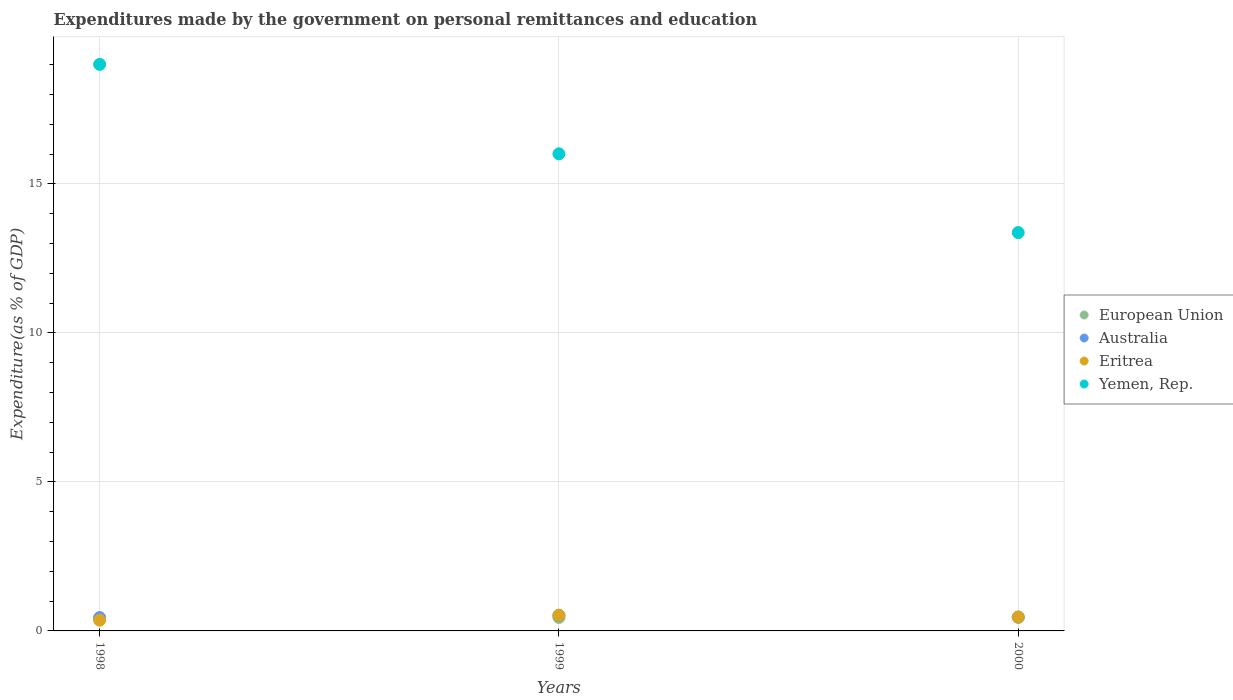How many different coloured dotlines are there?
Keep it short and to the point. 4. What is the expenditures made by the government on personal remittances and education in European Union in 2000?
Offer a terse response. 0.47. Across all years, what is the maximum expenditures made by the government on personal remittances and education in Eritrea?
Provide a succinct answer. 0.53. Across all years, what is the minimum expenditures made by the government on personal remittances and education in Yemen, Rep.?
Make the answer very short. 13.37. In which year was the expenditures made by the government on personal remittances and education in European Union maximum?
Keep it short and to the point. 2000. In which year was the expenditures made by the government on personal remittances and education in Eritrea minimum?
Provide a short and direct response. 1998. What is the total expenditures made by the government on personal remittances and education in European Union in the graph?
Provide a succinct answer. 1.36. What is the difference between the expenditures made by the government on personal remittances and education in Eritrea in 1998 and that in 1999?
Your answer should be compact. -0.17. What is the difference between the expenditures made by the government on personal remittances and education in Eritrea in 1998 and the expenditures made by the government on personal remittances and education in Yemen, Rep. in 2000?
Make the answer very short. -13.01. What is the average expenditures made by the government on personal remittances and education in Yemen, Rep. per year?
Offer a terse response. 16.13. In the year 1999, what is the difference between the expenditures made by the government on personal remittances and education in European Union and expenditures made by the government on personal remittances and education in Yemen, Rep.?
Your answer should be very brief. -15.56. In how many years, is the expenditures made by the government on personal remittances and education in European Union greater than 8 %?
Ensure brevity in your answer.  0. What is the ratio of the expenditures made by the government on personal remittances and education in Australia in 1998 to that in 2000?
Offer a terse response. 0.97. Is the expenditures made by the government on personal remittances and education in Yemen, Rep. in 1998 less than that in 1999?
Offer a terse response. No. What is the difference between the highest and the second highest expenditures made by the government on personal remittances and education in Yemen, Rep.?
Offer a terse response. 3. What is the difference between the highest and the lowest expenditures made by the government on personal remittances and education in Eritrea?
Offer a terse response. 0.17. In how many years, is the expenditures made by the government on personal remittances and education in Yemen, Rep. greater than the average expenditures made by the government on personal remittances and education in Yemen, Rep. taken over all years?
Ensure brevity in your answer.  1. Is the sum of the expenditures made by the government on personal remittances and education in European Union in 1998 and 2000 greater than the maximum expenditures made by the government on personal remittances and education in Eritrea across all years?
Your answer should be very brief. Yes. Is it the case that in every year, the sum of the expenditures made by the government on personal remittances and education in Eritrea and expenditures made by the government on personal remittances and education in European Union  is greater than the expenditures made by the government on personal remittances and education in Yemen, Rep.?
Give a very brief answer. No. Is the expenditures made by the government on personal remittances and education in Yemen, Rep. strictly greater than the expenditures made by the government on personal remittances and education in Eritrea over the years?
Your answer should be very brief. Yes. How many years are there in the graph?
Provide a short and direct response. 3. Are the values on the major ticks of Y-axis written in scientific E-notation?
Your answer should be very brief. No. Where does the legend appear in the graph?
Provide a succinct answer. Center right. What is the title of the graph?
Provide a short and direct response. Expenditures made by the government on personal remittances and education. Does "Sudan" appear as one of the legend labels in the graph?
Your answer should be very brief. No. What is the label or title of the Y-axis?
Provide a short and direct response. Expenditure(as % of GDP). What is the Expenditure(as % of GDP) in European Union in 1998?
Give a very brief answer. 0.44. What is the Expenditure(as % of GDP) of Australia in 1998?
Make the answer very short. 0.45. What is the Expenditure(as % of GDP) in Eritrea in 1998?
Offer a very short reply. 0.36. What is the Expenditure(as % of GDP) of Yemen, Rep. in 1998?
Give a very brief answer. 19.01. What is the Expenditure(as % of GDP) of European Union in 1999?
Provide a succinct answer. 0.45. What is the Expenditure(as % of GDP) of Australia in 1999?
Make the answer very short. 0.52. What is the Expenditure(as % of GDP) in Eritrea in 1999?
Your response must be concise. 0.53. What is the Expenditure(as % of GDP) in Yemen, Rep. in 1999?
Your response must be concise. 16.01. What is the Expenditure(as % of GDP) of European Union in 2000?
Your answer should be compact. 0.47. What is the Expenditure(as % of GDP) of Australia in 2000?
Provide a succinct answer. 0.46. What is the Expenditure(as % of GDP) in Eritrea in 2000?
Provide a short and direct response. 0.47. What is the Expenditure(as % of GDP) in Yemen, Rep. in 2000?
Ensure brevity in your answer.  13.37. Across all years, what is the maximum Expenditure(as % of GDP) in European Union?
Provide a short and direct response. 0.47. Across all years, what is the maximum Expenditure(as % of GDP) in Australia?
Provide a short and direct response. 0.52. Across all years, what is the maximum Expenditure(as % of GDP) of Eritrea?
Offer a very short reply. 0.53. Across all years, what is the maximum Expenditure(as % of GDP) of Yemen, Rep.?
Your answer should be compact. 19.01. Across all years, what is the minimum Expenditure(as % of GDP) of European Union?
Keep it short and to the point. 0.44. Across all years, what is the minimum Expenditure(as % of GDP) of Australia?
Your answer should be compact. 0.45. Across all years, what is the minimum Expenditure(as % of GDP) in Eritrea?
Provide a short and direct response. 0.36. Across all years, what is the minimum Expenditure(as % of GDP) of Yemen, Rep.?
Your answer should be compact. 13.37. What is the total Expenditure(as % of GDP) in European Union in the graph?
Ensure brevity in your answer.  1.36. What is the total Expenditure(as % of GDP) in Australia in the graph?
Your answer should be very brief. 1.43. What is the total Expenditure(as % of GDP) in Eritrea in the graph?
Your answer should be compact. 1.35. What is the total Expenditure(as % of GDP) in Yemen, Rep. in the graph?
Make the answer very short. 48.38. What is the difference between the Expenditure(as % of GDP) of European Union in 1998 and that in 1999?
Make the answer very short. -0.01. What is the difference between the Expenditure(as % of GDP) in Australia in 1998 and that in 1999?
Your response must be concise. -0.08. What is the difference between the Expenditure(as % of GDP) in Eritrea in 1998 and that in 1999?
Keep it short and to the point. -0.17. What is the difference between the Expenditure(as % of GDP) of Yemen, Rep. in 1998 and that in 1999?
Ensure brevity in your answer.  3. What is the difference between the Expenditure(as % of GDP) of European Union in 1998 and that in 2000?
Your response must be concise. -0.03. What is the difference between the Expenditure(as % of GDP) in Australia in 1998 and that in 2000?
Ensure brevity in your answer.  -0.01. What is the difference between the Expenditure(as % of GDP) of Eritrea in 1998 and that in 2000?
Your answer should be very brief. -0.1. What is the difference between the Expenditure(as % of GDP) of Yemen, Rep. in 1998 and that in 2000?
Keep it short and to the point. 5.64. What is the difference between the Expenditure(as % of GDP) in European Union in 1999 and that in 2000?
Ensure brevity in your answer.  -0.01. What is the difference between the Expenditure(as % of GDP) of Australia in 1999 and that in 2000?
Provide a succinct answer. 0.06. What is the difference between the Expenditure(as % of GDP) of Eritrea in 1999 and that in 2000?
Make the answer very short. 0.06. What is the difference between the Expenditure(as % of GDP) in Yemen, Rep. in 1999 and that in 2000?
Make the answer very short. 2.64. What is the difference between the Expenditure(as % of GDP) in European Union in 1998 and the Expenditure(as % of GDP) in Australia in 1999?
Make the answer very short. -0.08. What is the difference between the Expenditure(as % of GDP) in European Union in 1998 and the Expenditure(as % of GDP) in Eritrea in 1999?
Your response must be concise. -0.09. What is the difference between the Expenditure(as % of GDP) in European Union in 1998 and the Expenditure(as % of GDP) in Yemen, Rep. in 1999?
Provide a short and direct response. -15.57. What is the difference between the Expenditure(as % of GDP) of Australia in 1998 and the Expenditure(as % of GDP) of Eritrea in 1999?
Your response must be concise. -0.08. What is the difference between the Expenditure(as % of GDP) in Australia in 1998 and the Expenditure(as % of GDP) in Yemen, Rep. in 1999?
Ensure brevity in your answer.  -15.56. What is the difference between the Expenditure(as % of GDP) in Eritrea in 1998 and the Expenditure(as % of GDP) in Yemen, Rep. in 1999?
Make the answer very short. -15.65. What is the difference between the Expenditure(as % of GDP) of European Union in 1998 and the Expenditure(as % of GDP) of Australia in 2000?
Your response must be concise. -0.02. What is the difference between the Expenditure(as % of GDP) of European Union in 1998 and the Expenditure(as % of GDP) of Eritrea in 2000?
Your answer should be compact. -0.03. What is the difference between the Expenditure(as % of GDP) of European Union in 1998 and the Expenditure(as % of GDP) of Yemen, Rep. in 2000?
Keep it short and to the point. -12.93. What is the difference between the Expenditure(as % of GDP) in Australia in 1998 and the Expenditure(as % of GDP) in Eritrea in 2000?
Your answer should be compact. -0.02. What is the difference between the Expenditure(as % of GDP) of Australia in 1998 and the Expenditure(as % of GDP) of Yemen, Rep. in 2000?
Your answer should be compact. -12.92. What is the difference between the Expenditure(as % of GDP) of Eritrea in 1998 and the Expenditure(as % of GDP) of Yemen, Rep. in 2000?
Provide a succinct answer. -13.01. What is the difference between the Expenditure(as % of GDP) of European Union in 1999 and the Expenditure(as % of GDP) of Australia in 2000?
Offer a terse response. -0.01. What is the difference between the Expenditure(as % of GDP) in European Union in 1999 and the Expenditure(as % of GDP) in Eritrea in 2000?
Offer a very short reply. -0.01. What is the difference between the Expenditure(as % of GDP) of European Union in 1999 and the Expenditure(as % of GDP) of Yemen, Rep. in 2000?
Keep it short and to the point. -12.91. What is the difference between the Expenditure(as % of GDP) in Australia in 1999 and the Expenditure(as % of GDP) in Eritrea in 2000?
Ensure brevity in your answer.  0.06. What is the difference between the Expenditure(as % of GDP) of Australia in 1999 and the Expenditure(as % of GDP) of Yemen, Rep. in 2000?
Ensure brevity in your answer.  -12.84. What is the difference between the Expenditure(as % of GDP) of Eritrea in 1999 and the Expenditure(as % of GDP) of Yemen, Rep. in 2000?
Offer a terse response. -12.84. What is the average Expenditure(as % of GDP) in European Union per year?
Give a very brief answer. 0.45. What is the average Expenditure(as % of GDP) in Australia per year?
Your response must be concise. 0.48. What is the average Expenditure(as % of GDP) of Eritrea per year?
Provide a succinct answer. 0.45. What is the average Expenditure(as % of GDP) in Yemen, Rep. per year?
Your answer should be very brief. 16.13. In the year 1998, what is the difference between the Expenditure(as % of GDP) in European Union and Expenditure(as % of GDP) in Australia?
Your answer should be very brief. -0.01. In the year 1998, what is the difference between the Expenditure(as % of GDP) in European Union and Expenditure(as % of GDP) in Eritrea?
Offer a very short reply. 0.08. In the year 1998, what is the difference between the Expenditure(as % of GDP) in European Union and Expenditure(as % of GDP) in Yemen, Rep.?
Offer a terse response. -18.57. In the year 1998, what is the difference between the Expenditure(as % of GDP) of Australia and Expenditure(as % of GDP) of Eritrea?
Ensure brevity in your answer.  0.09. In the year 1998, what is the difference between the Expenditure(as % of GDP) of Australia and Expenditure(as % of GDP) of Yemen, Rep.?
Your response must be concise. -18.56. In the year 1998, what is the difference between the Expenditure(as % of GDP) of Eritrea and Expenditure(as % of GDP) of Yemen, Rep.?
Keep it short and to the point. -18.65. In the year 1999, what is the difference between the Expenditure(as % of GDP) of European Union and Expenditure(as % of GDP) of Australia?
Keep it short and to the point. -0.07. In the year 1999, what is the difference between the Expenditure(as % of GDP) of European Union and Expenditure(as % of GDP) of Eritrea?
Your answer should be very brief. -0.08. In the year 1999, what is the difference between the Expenditure(as % of GDP) in European Union and Expenditure(as % of GDP) in Yemen, Rep.?
Your answer should be compact. -15.56. In the year 1999, what is the difference between the Expenditure(as % of GDP) in Australia and Expenditure(as % of GDP) in Eritrea?
Give a very brief answer. -0.01. In the year 1999, what is the difference between the Expenditure(as % of GDP) of Australia and Expenditure(as % of GDP) of Yemen, Rep.?
Provide a short and direct response. -15.49. In the year 1999, what is the difference between the Expenditure(as % of GDP) of Eritrea and Expenditure(as % of GDP) of Yemen, Rep.?
Give a very brief answer. -15.48. In the year 2000, what is the difference between the Expenditure(as % of GDP) of European Union and Expenditure(as % of GDP) of Australia?
Provide a succinct answer. 0.01. In the year 2000, what is the difference between the Expenditure(as % of GDP) of European Union and Expenditure(as % of GDP) of Eritrea?
Your answer should be compact. 0. In the year 2000, what is the difference between the Expenditure(as % of GDP) of European Union and Expenditure(as % of GDP) of Yemen, Rep.?
Offer a terse response. -12.9. In the year 2000, what is the difference between the Expenditure(as % of GDP) in Australia and Expenditure(as % of GDP) in Eritrea?
Keep it short and to the point. -0.01. In the year 2000, what is the difference between the Expenditure(as % of GDP) of Australia and Expenditure(as % of GDP) of Yemen, Rep.?
Provide a succinct answer. -12.91. In the year 2000, what is the difference between the Expenditure(as % of GDP) of Eritrea and Expenditure(as % of GDP) of Yemen, Rep.?
Offer a terse response. -12.9. What is the ratio of the Expenditure(as % of GDP) of European Union in 1998 to that in 1999?
Offer a very short reply. 0.97. What is the ratio of the Expenditure(as % of GDP) in Australia in 1998 to that in 1999?
Your answer should be very brief. 0.85. What is the ratio of the Expenditure(as % of GDP) in Eritrea in 1998 to that in 1999?
Offer a very short reply. 0.68. What is the ratio of the Expenditure(as % of GDP) in Yemen, Rep. in 1998 to that in 1999?
Offer a terse response. 1.19. What is the ratio of the Expenditure(as % of GDP) of European Union in 1998 to that in 2000?
Ensure brevity in your answer.  0.94. What is the ratio of the Expenditure(as % of GDP) in Australia in 1998 to that in 2000?
Your answer should be compact. 0.97. What is the ratio of the Expenditure(as % of GDP) in Eritrea in 1998 to that in 2000?
Provide a short and direct response. 0.78. What is the ratio of the Expenditure(as % of GDP) of Yemen, Rep. in 1998 to that in 2000?
Make the answer very short. 1.42. What is the ratio of the Expenditure(as % of GDP) in European Union in 1999 to that in 2000?
Your answer should be compact. 0.97. What is the ratio of the Expenditure(as % of GDP) in Australia in 1999 to that in 2000?
Offer a very short reply. 1.14. What is the ratio of the Expenditure(as % of GDP) in Eritrea in 1999 to that in 2000?
Your response must be concise. 1.13. What is the ratio of the Expenditure(as % of GDP) of Yemen, Rep. in 1999 to that in 2000?
Keep it short and to the point. 1.2. What is the difference between the highest and the second highest Expenditure(as % of GDP) in European Union?
Provide a succinct answer. 0.01. What is the difference between the highest and the second highest Expenditure(as % of GDP) of Australia?
Your answer should be compact. 0.06. What is the difference between the highest and the second highest Expenditure(as % of GDP) of Eritrea?
Ensure brevity in your answer.  0.06. What is the difference between the highest and the second highest Expenditure(as % of GDP) of Yemen, Rep.?
Offer a terse response. 3. What is the difference between the highest and the lowest Expenditure(as % of GDP) of European Union?
Offer a very short reply. 0.03. What is the difference between the highest and the lowest Expenditure(as % of GDP) in Australia?
Offer a very short reply. 0.08. What is the difference between the highest and the lowest Expenditure(as % of GDP) in Eritrea?
Offer a terse response. 0.17. What is the difference between the highest and the lowest Expenditure(as % of GDP) in Yemen, Rep.?
Make the answer very short. 5.64. 